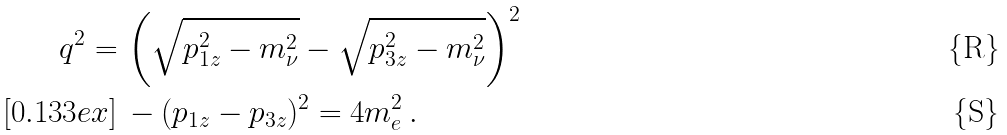Convert formula to latex. <formula><loc_0><loc_0><loc_500><loc_500>q ^ { 2 } = & \, \left ( \sqrt { p _ { 1 z } ^ { 2 } - m _ { \nu } ^ { 2 } } - \sqrt { p _ { 3 z } ^ { 2 } - m _ { \nu } ^ { 2 } } \right ) ^ { 2 } \\ [ 0 . 1 3 3 e x ] & \, - ( p _ { 1 z } - p _ { 3 z } ) ^ { 2 } = 4 m _ { e } ^ { 2 } \, .</formula> 